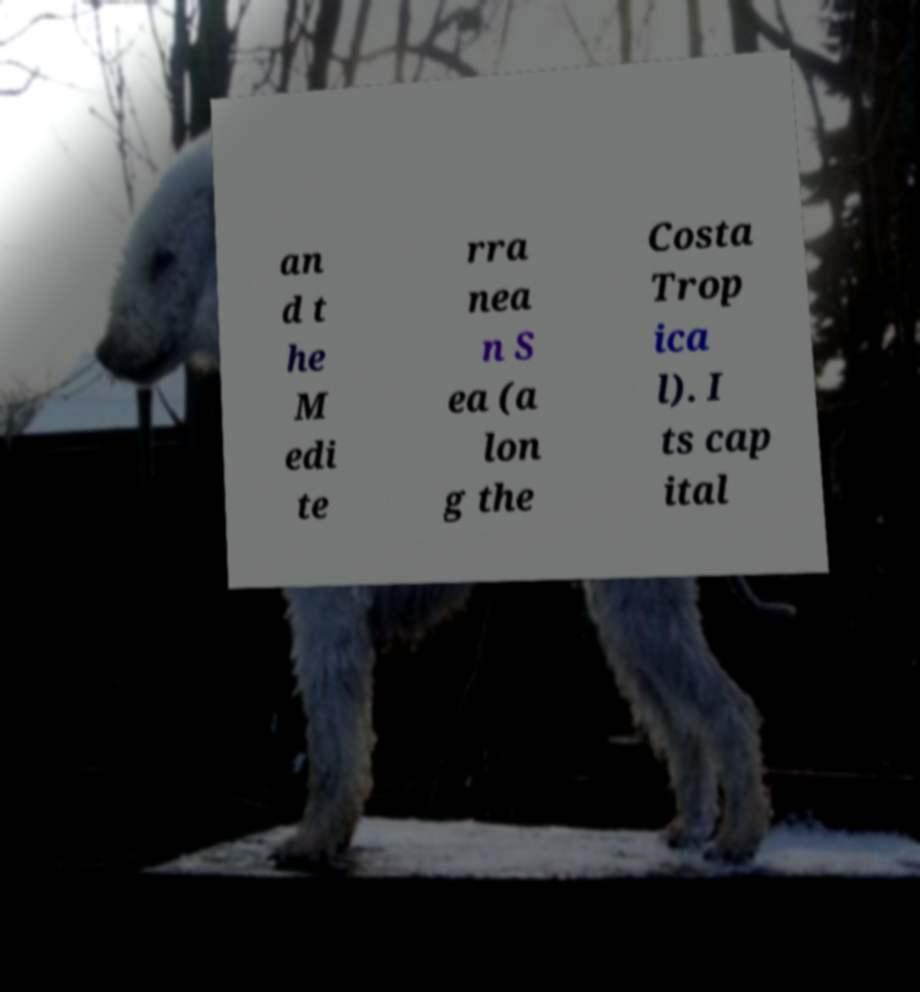Can you read and provide the text displayed in the image?This photo seems to have some interesting text. Can you extract and type it out for me? an d t he M edi te rra nea n S ea (a lon g the Costa Trop ica l). I ts cap ital 